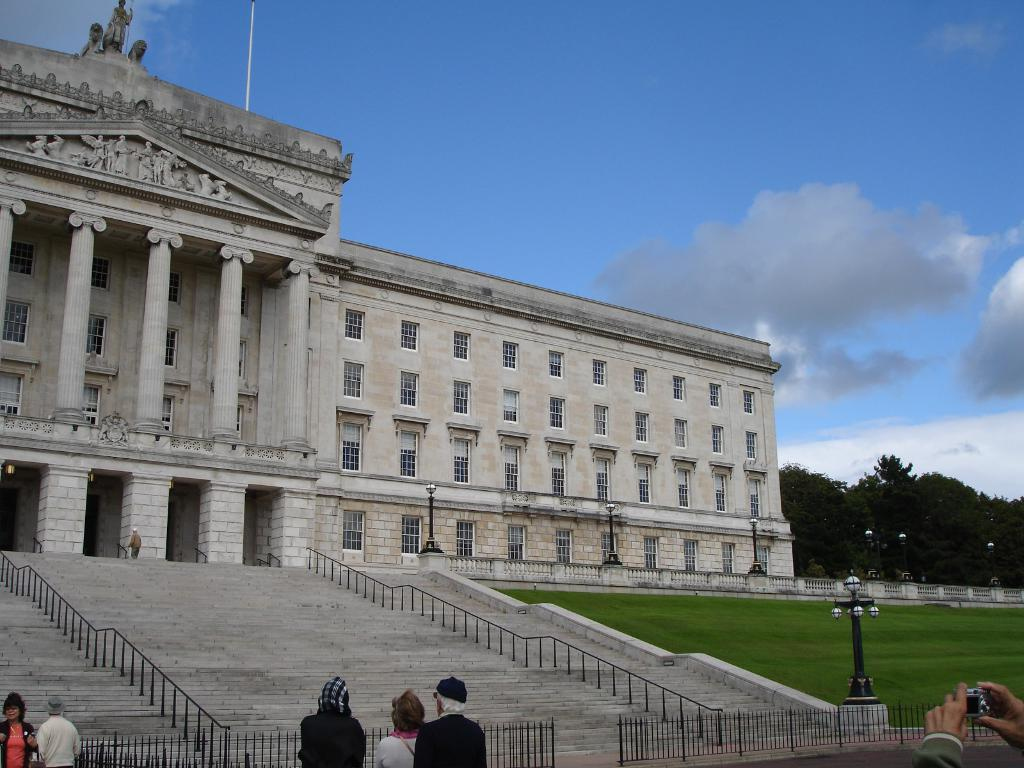What type of structure is present in the image? There is a building in the image. What architectural feature can be seen in the image? There are steps in the image. What type of barrier is present in the image? There is a fence in the image. Can you describe the people visible in the image? There are people visible in the image. What type of vegetation is present in the image? There is grass in the image. What can be seen in the background of the image? There are trees and the sky visible in the background of the image. What type of fuel is required to operate the brake in the image? There is no brake or fuel present in the image; it features a building, steps, a fence, people, grass, trees, and the sky. What type of riddle can be solved using the information in the image? There is no riddle present in the image; it is a scene featuring a building, steps, a fence, people, grass, trees, and the sky. 